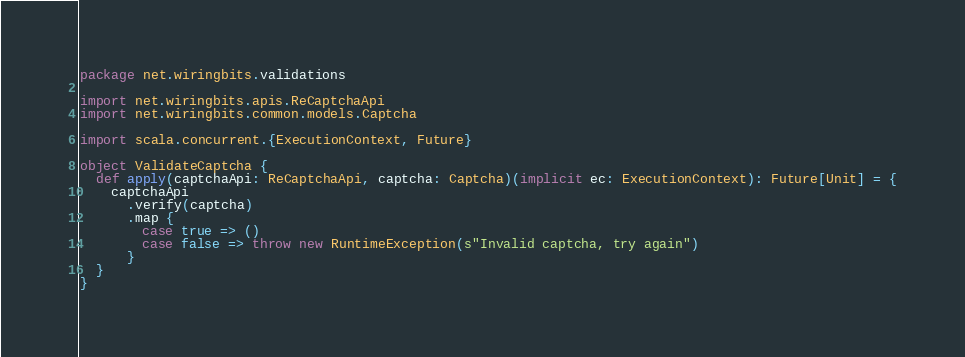<code> <loc_0><loc_0><loc_500><loc_500><_Scala_>package net.wiringbits.validations

import net.wiringbits.apis.ReCaptchaApi
import net.wiringbits.common.models.Captcha

import scala.concurrent.{ExecutionContext, Future}

object ValidateCaptcha {
  def apply(captchaApi: ReCaptchaApi, captcha: Captcha)(implicit ec: ExecutionContext): Future[Unit] = {
    captchaApi
      .verify(captcha)
      .map {
        case true => ()
        case false => throw new RuntimeException(s"Invalid captcha, try again")
      }
  }
}
</code> 